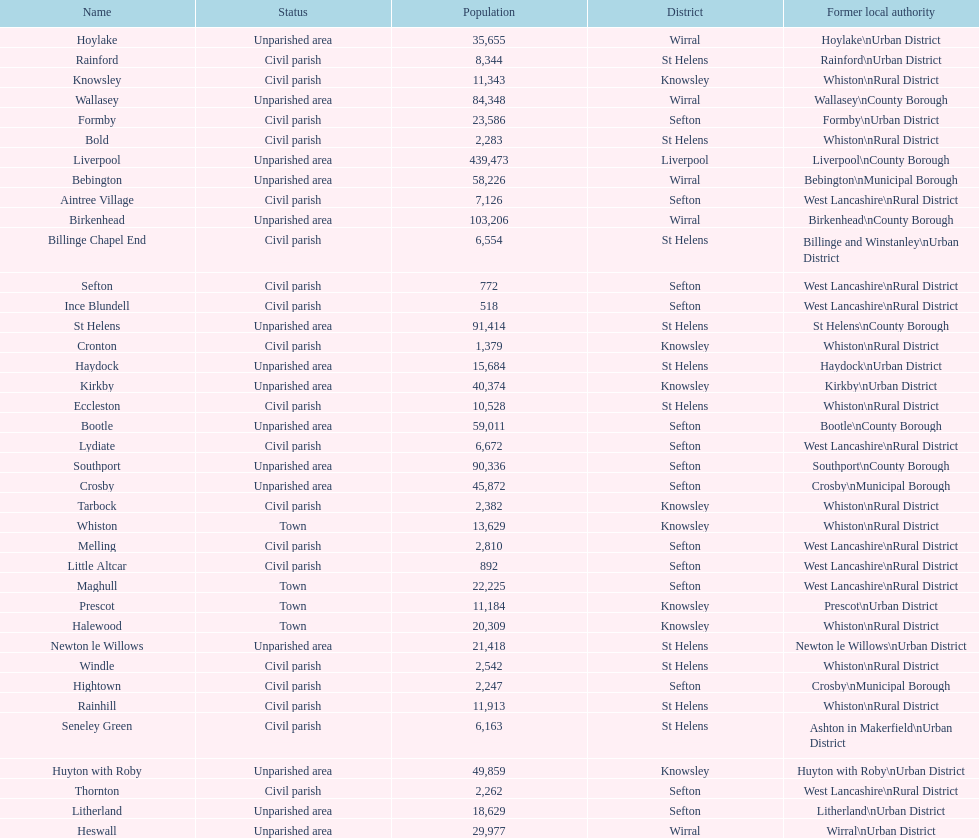What is the largest area in terms of population? Liverpool. 